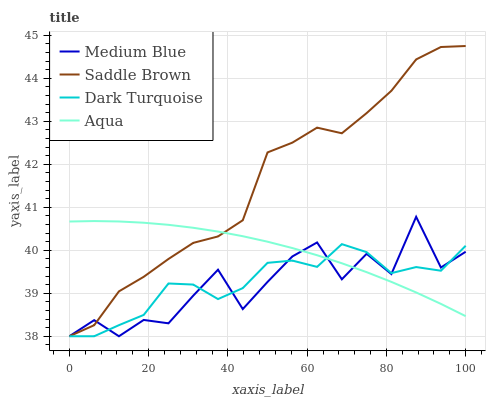Does Dark Turquoise have the minimum area under the curve?
Answer yes or no. No. Does Dark Turquoise have the maximum area under the curve?
Answer yes or no. No. Is Dark Turquoise the smoothest?
Answer yes or no. No. Is Dark Turquoise the roughest?
Answer yes or no. No. Does Medium Blue have the highest value?
Answer yes or no. No. 